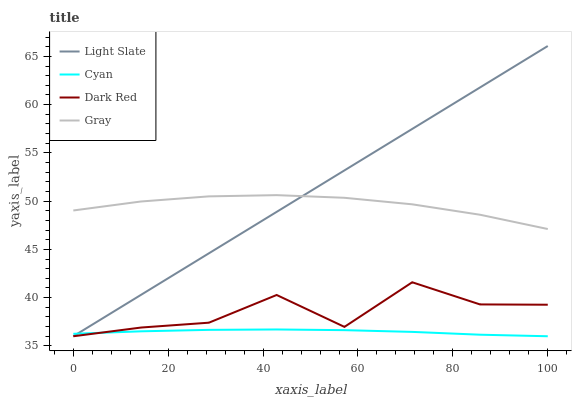Does Cyan have the minimum area under the curve?
Answer yes or no. Yes. Does Light Slate have the maximum area under the curve?
Answer yes or no. Yes. Does Gray have the minimum area under the curve?
Answer yes or no. No. Does Gray have the maximum area under the curve?
Answer yes or no. No. Is Light Slate the smoothest?
Answer yes or no. Yes. Is Dark Red the roughest?
Answer yes or no. Yes. Is Cyan the smoothest?
Answer yes or no. No. Is Cyan the roughest?
Answer yes or no. No. Does Light Slate have the lowest value?
Answer yes or no. Yes. Does Gray have the lowest value?
Answer yes or no. No. Does Light Slate have the highest value?
Answer yes or no. Yes. Does Gray have the highest value?
Answer yes or no. No. Is Cyan less than Gray?
Answer yes or no. Yes. Is Gray greater than Dark Red?
Answer yes or no. Yes. Does Dark Red intersect Cyan?
Answer yes or no. Yes. Is Dark Red less than Cyan?
Answer yes or no. No. Is Dark Red greater than Cyan?
Answer yes or no. No. Does Cyan intersect Gray?
Answer yes or no. No. 